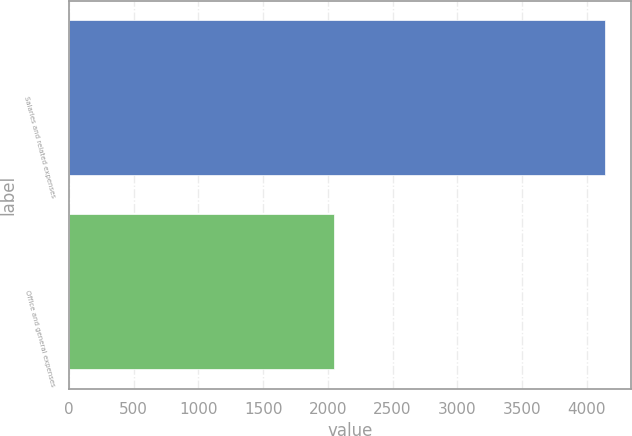Convert chart. <chart><loc_0><loc_0><loc_500><loc_500><bar_chart><fcel>Salaries and related expenses<fcel>Office and general expenses<nl><fcel>4139.2<fcel>2044.8<nl></chart> 